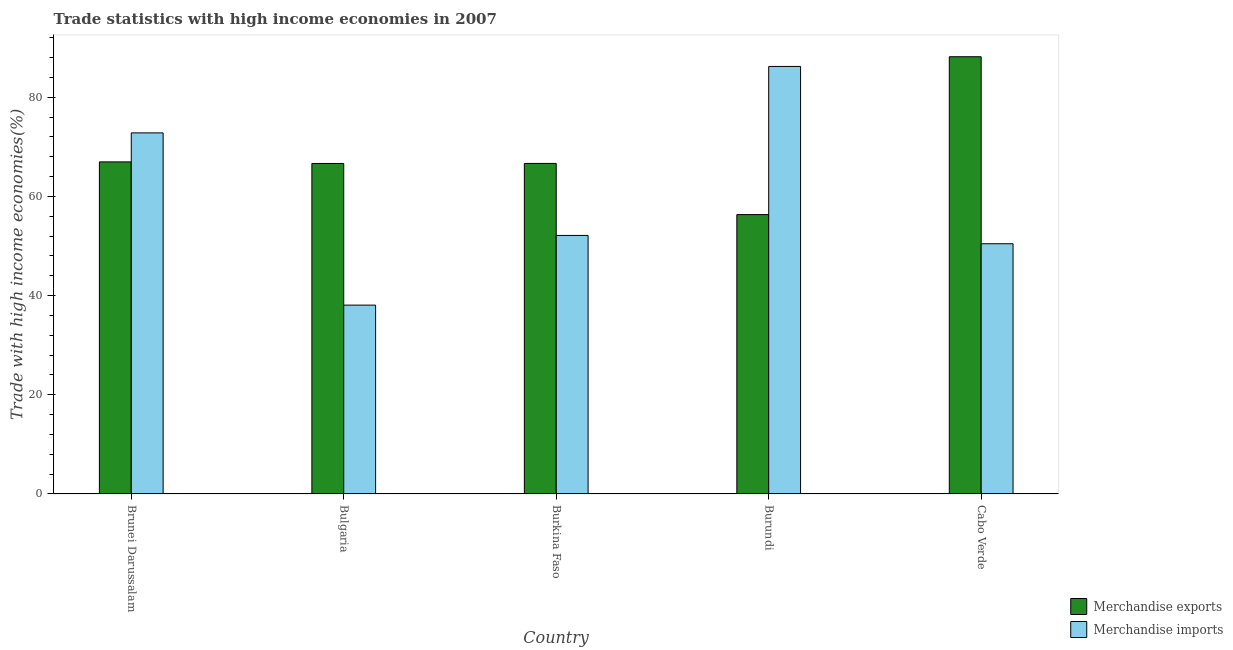How many different coloured bars are there?
Provide a short and direct response. 2. Are the number of bars per tick equal to the number of legend labels?
Offer a terse response. Yes. How many bars are there on the 3rd tick from the left?
Your response must be concise. 2. What is the label of the 3rd group of bars from the left?
Keep it short and to the point. Burkina Faso. What is the merchandise imports in Bulgaria?
Provide a short and direct response. 38.09. Across all countries, what is the maximum merchandise exports?
Your answer should be very brief. 88.18. Across all countries, what is the minimum merchandise exports?
Offer a very short reply. 56.35. In which country was the merchandise imports maximum?
Offer a very short reply. Burundi. In which country was the merchandise imports minimum?
Your answer should be very brief. Bulgaria. What is the total merchandise exports in the graph?
Your answer should be compact. 344.83. What is the difference between the merchandise imports in Bulgaria and that in Cabo Verde?
Your answer should be compact. -12.38. What is the difference between the merchandise imports in Burkina Faso and the merchandise exports in Bulgaria?
Your response must be concise. -14.51. What is the average merchandise imports per country?
Offer a very short reply. 59.95. What is the difference between the merchandise exports and merchandise imports in Bulgaria?
Keep it short and to the point. 28.57. What is the ratio of the merchandise exports in Brunei Darussalam to that in Burundi?
Offer a very short reply. 1.19. Is the merchandise imports in Burkina Faso less than that in Cabo Verde?
Offer a terse response. No. What is the difference between the highest and the second highest merchandise imports?
Keep it short and to the point. 13.4. What is the difference between the highest and the lowest merchandise imports?
Offer a very short reply. 48.14. In how many countries, is the merchandise exports greater than the average merchandise exports taken over all countries?
Give a very brief answer. 1. Is the sum of the merchandise imports in Bulgaria and Burkina Faso greater than the maximum merchandise exports across all countries?
Your response must be concise. Yes. What does the 2nd bar from the right in Burundi represents?
Make the answer very short. Merchandise exports. How many bars are there?
Your answer should be very brief. 10. Are all the bars in the graph horizontal?
Your response must be concise. No. How many countries are there in the graph?
Your answer should be compact. 5. Are the values on the major ticks of Y-axis written in scientific E-notation?
Your response must be concise. No. How many legend labels are there?
Offer a very short reply. 2. How are the legend labels stacked?
Provide a short and direct response. Vertical. What is the title of the graph?
Your answer should be compact. Trade statistics with high income economies in 2007. Does "Net savings(excluding particulate emission damage)" appear as one of the legend labels in the graph?
Offer a very short reply. No. What is the label or title of the Y-axis?
Your answer should be compact. Trade with high income economies(%). What is the Trade with high income economies(%) of Merchandise exports in Brunei Darussalam?
Offer a very short reply. 66.98. What is the Trade with high income economies(%) of Merchandise imports in Brunei Darussalam?
Offer a very short reply. 72.83. What is the Trade with high income economies(%) of Merchandise exports in Bulgaria?
Your answer should be very brief. 66.65. What is the Trade with high income economies(%) of Merchandise imports in Bulgaria?
Your answer should be compact. 38.09. What is the Trade with high income economies(%) of Merchandise exports in Burkina Faso?
Offer a very short reply. 66.67. What is the Trade with high income economies(%) of Merchandise imports in Burkina Faso?
Keep it short and to the point. 52.14. What is the Trade with high income economies(%) in Merchandise exports in Burundi?
Make the answer very short. 56.35. What is the Trade with high income economies(%) of Merchandise imports in Burundi?
Make the answer very short. 86.23. What is the Trade with high income economies(%) in Merchandise exports in Cabo Verde?
Offer a terse response. 88.18. What is the Trade with high income economies(%) of Merchandise imports in Cabo Verde?
Ensure brevity in your answer.  50.47. Across all countries, what is the maximum Trade with high income economies(%) in Merchandise exports?
Your answer should be very brief. 88.18. Across all countries, what is the maximum Trade with high income economies(%) of Merchandise imports?
Give a very brief answer. 86.23. Across all countries, what is the minimum Trade with high income economies(%) in Merchandise exports?
Your answer should be compact. 56.35. Across all countries, what is the minimum Trade with high income economies(%) of Merchandise imports?
Provide a succinct answer. 38.09. What is the total Trade with high income economies(%) in Merchandise exports in the graph?
Ensure brevity in your answer.  344.83. What is the total Trade with high income economies(%) of Merchandise imports in the graph?
Provide a short and direct response. 299.75. What is the difference between the Trade with high income economies(%) of Merchandise exports in Brunei Darussalam and that in Bulgaria?
Provide a short and direct response. 0.32. What is the difference between the Trade with high income economies(%) of Merchandise imports in Brunei Darussalam and that in Bulgaria?
Provide a short and direct response. 34.74. What is the difference between the Trade with high income economies(%) in Merchandise exports in Brunei Darussalam and that in Burkina Faso?
Your answer should be compact. 0.31. What is the difference between the Trade with high income economies(%) in Merchandise imports in Brunei Darussalam and that in Burkina Faso?
Give a very brief answer. 20.68. What is the difference between the Trade with high income economies(%) in Merchandise exports in Brunei Darussalam and that in Burundi?
Your answer should be compact. 10.63. What is the difference between the Trade with high income economies(%) in Merchandise imports in Brunei Darussalam and that in Burundi?
Offer a terse response. -13.4. What is the difference between the Trade with high income economies(%) of Merchandise exports in Brunei Darussalam and that in Cabo Verde?
Your response must be concise. -21.21. What is the difference between the Trade with high income economies(%) in Merchandise imports in Brunei Darussalam and that in Cabo Verde?
Your answer should be compact. 22.36. What is the difference between the Trade with high income economies(%) in Merchandise exports in Bulgaria and that in Burkina Faso?
Provide a short and direct response. -0.01. What is the difference between the Trade with high income economies(%) in Merchandise imports in Bulgaria and that in Burkina Faso?
Your answer should be compact. -14.05. What is the difference between the Trade with high income economies(%) in Merchandise exports in Bulgaria and that in Burundi?
Your answer should be compact. 10.31. What is the difference between the Trade with high income economies(%) of Merchandise imports in Bulgaria and that in Burundi?
Keep it short and to the point. -48.14. What is the difference between the Trade with high income economies(%) in Merchandise exports in Bulgaria and that in Cabo Verde?
Provide a succinct answer. -21.53. What is the difference between the Trade with high income economies(%) in Merchandise imports in Bulgaria and that in Cabo Verde?
Provide a succinct answer. -12.38. What is the difference between the Trade with high income economies(%) of Merchandise exports in Burkina Faso and that in Burundi?
Offer a very short reply. 10.32. What is the difference between the Trade with high income economies(%) of Merchandise imports in Burkina Faso and that in Burundi?
Give a very brief answer. -34.08. What is the difference between the Trade with high income economies(%) in Merchandise exports in Burkina Faso and that in Cabo Verde?
Give a very brief answer. -21.52. What is the difference between the Trade with high income economies(%) of Merchandise imports in Burkina Faso and that in Cabo Verde?
Your response must be concise. 1.67. What is the difference between the Trade with high income economies(%) in Merchandise exports in Burundi and that in Cabo Verde?
Offer a very short reply. -31.84. What is the difference between the Trade with high income economies(%) of Merchandise imports in Burundi and that in Cabo Verde?
Provide a short and direct response. 35.76. What is the difference between the Trade with high income economies(%) of Merchandise exports in Brunei Darussalam and the Trade with high income economies(%) of Merchandise imports in Bulgaria?
Give a very brief answer. 28.89. What is the difference between the Trade with high income economies(%) in Merchandise exports in Brunei Darussalam and the Trade with high income economies(%) in Merchandise imports in Burkina Faso?
Provide a short and direct response. 14.83. What is the difference between the Trade with high income economies(%) of Merchandise exports in Brunei Darussalam and the Trade with high income economies(%) of Merchandise imports in Burundi?
Your response must be concise. -19.25. What is the difference between the Trade with high income economies(%) of Merchandise exports in Brunei Darussalam and the Trade with high income economies(%) of Merchandise imports in Cabo Verde?
Your response must be concise. 16.51. What is the difference between the Trade with high income economies(%) of Merchandise exports in Bulgaria and the Trade with high income economies(%) of Merchandise imports in Burkina Faso?
Give a very brief answer. 14.51. What is the difference between the Trade with high income economies(%) in Merchandise exports in Bulgaria and the Trade with high income economies(%) in Merchandise imports in Burundi?
Make the answer very short. -19.57. What is the difference between the Trade with high income economies(%) in Merchandise exports in Bulgaria and the Trade with high income economies(%) in Merchandise imports in Cabo Verde?
Ensure brevity in your answer.  16.19. What is the difference between the Trade with high income economies(%) of Merchandise exports in Burkina Faso and the Trade with high income economies(%) of Merchandise imports in Burundi?
Give a very brief answer. -19.56. What is the difference between the Trade with high income economies(%) in Merchandise exports in Burkina Faso and the Trade with high income economies(%) in Merchandise imports in Cabo Verde?
Offer a terse response. 16.2. What is the difference between the Trade with high income economies(%) in Merchandise exports in Burundi and the Trade with high income economies(%) in Merchandise imports in Cabo Verde?
Provide a short and direct response. 5.88. What is the average Trade with high income economies(%) in Merchandise exports per country?
Offer a terse response. 68.97. What is the average Trade with high income economies(%) of Merchandise imports per country?
Give a very brief answer. 59.95. What is the difference between the Trade with high income economies(%) of Merchandise exports and Trade with high income economies(%) of Merchandise imports in Brunei Darussalam?
Provide a short and direct response. -5.85. What is the difference between the Trade with high income economies(%) of Merchandise exports and Trade with high income economies(%) of Merchandise imports in Bulgaria?
Your answer should be very brief. 28.57. What is the difference between the Trade with high income economies(%) of Merchandise exports and Trade with high income economies(%) of Merchandise imports in Burkina Faso?
Keep it short and to the point. 14.52. What is the difference between the Trade with high income economies(%) of Merchandise exports and Trade with high income economies(%) of Merchandise imports in Burundi?
Ensure brevity in your answer.  -29.88. What is the difference between the Trade with high income economies(%) in Merchandise exports and Trade with high income economies(%) in Merchandise imports in Cabo Verde?
Your answer should be very brief. 37.72. What is the ratio of the Trade with high income economies(%) of Merchandise imports in Brunei Darussalam to that in Bulgaria?
Your answer should be very brief. 1.91. What is the ratio of the Trade with high income economies(%) in Merchandise exports in Brunei Darussalam to that in Burkina Faso?
Your response must be concise. 1. What is the ratio of the Trade with high income economies(%) in Merchandise imports in Brunei Darussalam to that in Burkina Faso?
Offer a terse response. 1.4. What is the ratio of the Trade with high income economies(%) in Merchandise exports in Brunei Darussalam to that in Burundi?
Your answer should be very brief. 1.19. What is the ratio of the Trade with high income economies(%) of Merchandise imports in Brunei Darussalam to that in Burundi?
Your answer should be compact. 0.84. What is the ratio of the Trade with high income economies(%) in Merchandise exports in Brunei Darussalam to that in Cabo Verde?
Your answer should be compact. 0.76. What is the ratio of the Trade with high income economies(%) in Merchandise imports in Brunei Darussalam to that in Cabo Verde?
Provide a succinct answer. 1.44. What is the ratio of the Trade with high income economies(%) of Merchandise imports in Bulgaria to that in Burkina Faso?
Provide a succinct answer. 0.73. What is the ratio of the Trade with high income economies(%) of Merchandise exports in Bulgaria to that in Burundi?
Offer a very short reply. 1.18. What is the ratio of the Trade with high income economies(%) in Merchandise imports in Bulgaria to that in Burundi?
Make the answer very short. 0.44. What is the ratio of the Trade with high income economies(%) in Merchandise exports in Bulgaria to that in Cabo Verde?
Your answer should be compact. 0.76. What is the ratio of the Trade with high income economies(%) of Merchandise imports in Bulgaria to that in Cabo Verde?
Make the answer very short. 0.75. What is the ratio of the Trade with high income economies(%) of Merchandise exports in Burkina Faso to that in Burundi?
Your answer should be compact. 1.18. What is the ratio of the Trade with high income economies(%) of Merchandise imports in Burkina Faso to that in Burundi?
Give a very brief answer. 0.6. What is the ratio of the Trade with high income economies(%) of Merchandise exports in Burkina Faso to that in Cabo Verde?
Your answer should be very brief. 0.76. What is the ratio of the Trade with high income economies(%) of Merchandise imports in Burkina Faso to that in Cabo Verde?
Ensure brevity in your answer.  1.03. What is the ratio of the Trade with high income economies(%) of Merchandise exports in Burundi to that in Cabo Verde?
Your answer should be compact. 0.64. What is the ratio of the Trade with high income economies(%) of Merchandise imports in Burundi to that in Cabo Verde?
Give a very brief answer. 1.71. What is the difference between the highest and the second highest Trade with high income economies(%) in Merchandise exports?
Keep it short and to the point. 21.21. What is the difference between the highest and the second highest Trade with high income economies(%) of Merchandise imports?
Offer a very short reply. 13.4. What is the difference between the highest and the lowest Trade with high income economies(%) in Merchandise exports?
Make the answer very short. 31.84. What is the difference between the highest and the lowest Trade with high income economies(%) of Merchandise imports?
Make the answer very short. 48.14. 